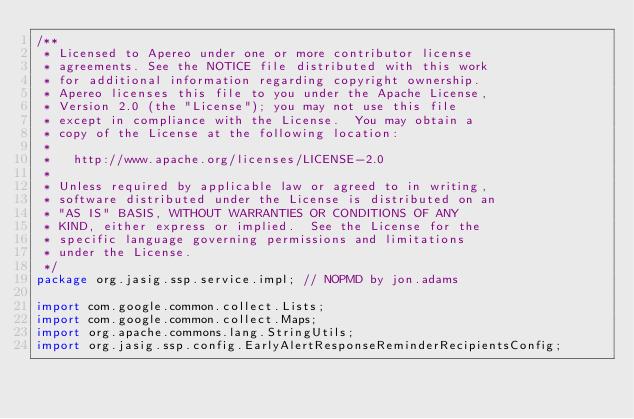<code> <loc_0><loc_0><loc_500><loc_500><_Java_>/**
 * Licensed to Apereo under one or more contributor license
 * agreements. See the NOTICE file distributed with this work
 * for additional information regarding copyright ownership.
 * Apereo licenses this file to you under the Apache License,
 * Version 2.0 (the "License"); you may not use this file
 * except in compliance with the License.  You may obtain a
 * copy of the License at the following location:
 *
 *   http://www.apache.org/licenses/LICENSE-2.0
 *
 * Unless required by applicable law or agreed to in writing,
 * software distributed under the License is distributed on an
 * "AS IS" BASIS, WITHOUT WARRANTIES OR CONDITIONS OF ANY
 * KIND, either express or implied.  See the License for the
 * specific language governing permissions and limitations
 * under the License.
 */
package org.jasig.ssp.service.impl; // NOPMD by jon.adams

import com.google.common.collect.Lists;
import com.google.common.collect.Maps;
import org.apache.commons.lang.StringUtils;
import org.jasig.ssp.config.EarlyAlertResponseReminderRecipientsConfig;</code> 